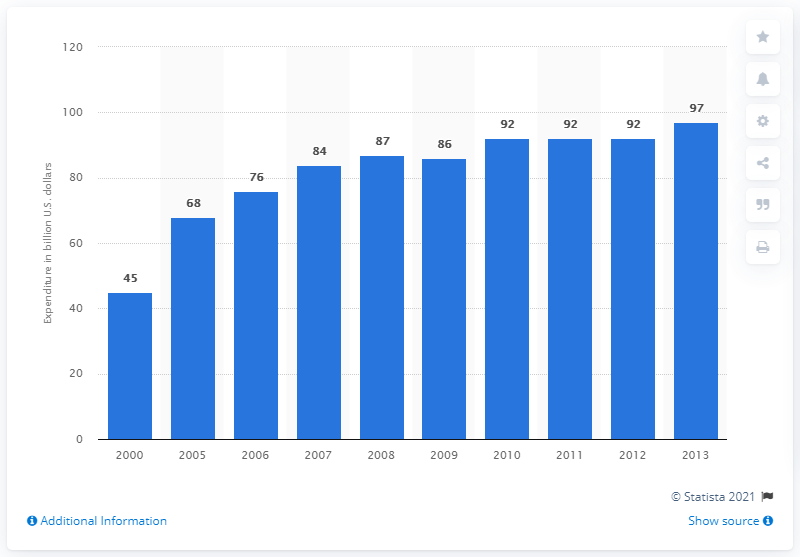Indicate a few pertinent items in this graphic. In 2000, the amount of money spent on research and development in the pharmaceutical industry in the United States, Europe, and Japan was approximately 45 billion US dollars. 